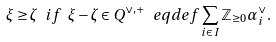Convert formula to latex. <formula><loc_0><loc_0><loc_500><loc_500>\xi \geq \zeta \ i f \ \xi - \zeta \in Q ^ { \lor , + } \ e q d e f \sum _ { i \in I } \mathbb { Z } _ { \geq 0 } \alpha _ { i } ^ { \lor } .</formula> 